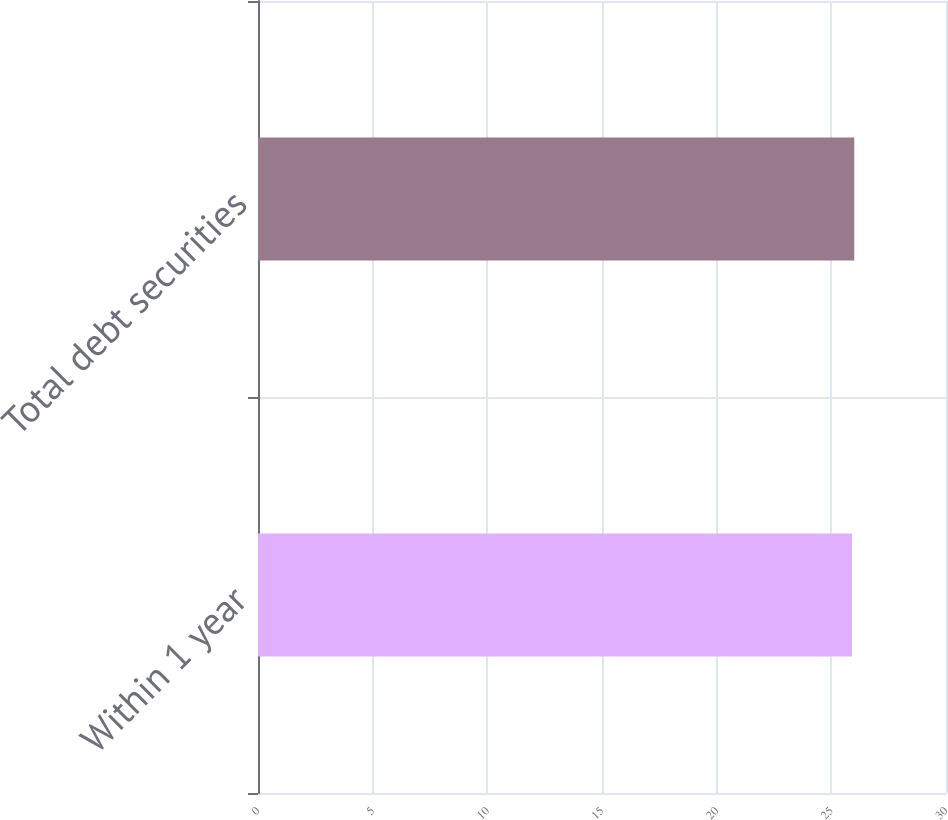Convert chart to OTSL. <chart><loc_0><loc_0><loc_500><loc_500><bar_chart><fcel>Within 1 year<fcel>Total debt securities<nl><fcel>25.9<fcel>26<nl></chart> 